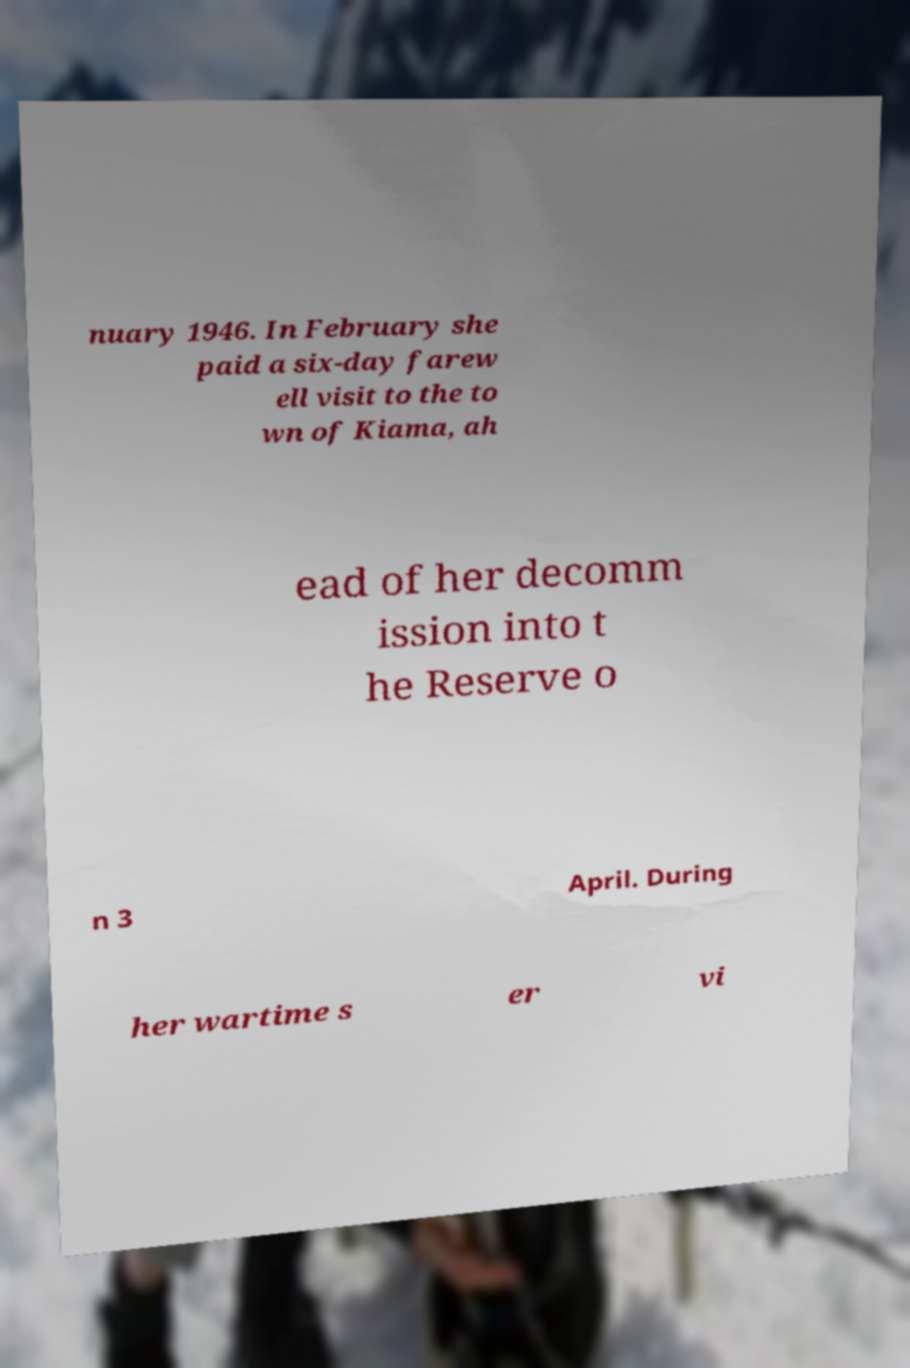Could you assist in decoding the text presented in this image and type it out clearly? nuary 1946. In February she paid a six-day farew ell visit to the to wn of Kiama, ah ead of her decomm ission into t he Reserve o n 3 April. During her wartime s er vi 